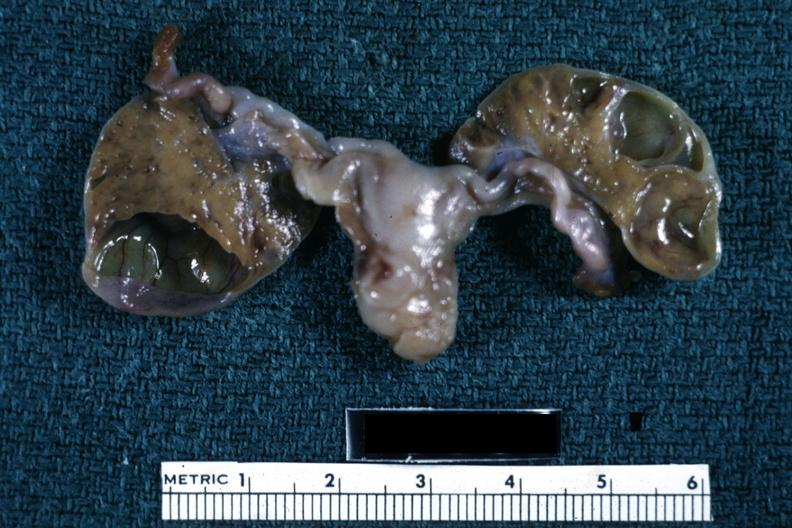does this image show fixed tissue close-up well shown tan-orange luteum tissue cysts in sliced ovaries three day old?
Answer the question using a single word or phrase. Yes 